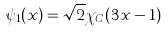Convert formula to latex. <formula><loc_0><loc_0><loc_500><loc_500>\psi _ { 1 } ( x ) = \sqrt { 2 } \chi _ { C } ( 3 x - 1 )</formula> 